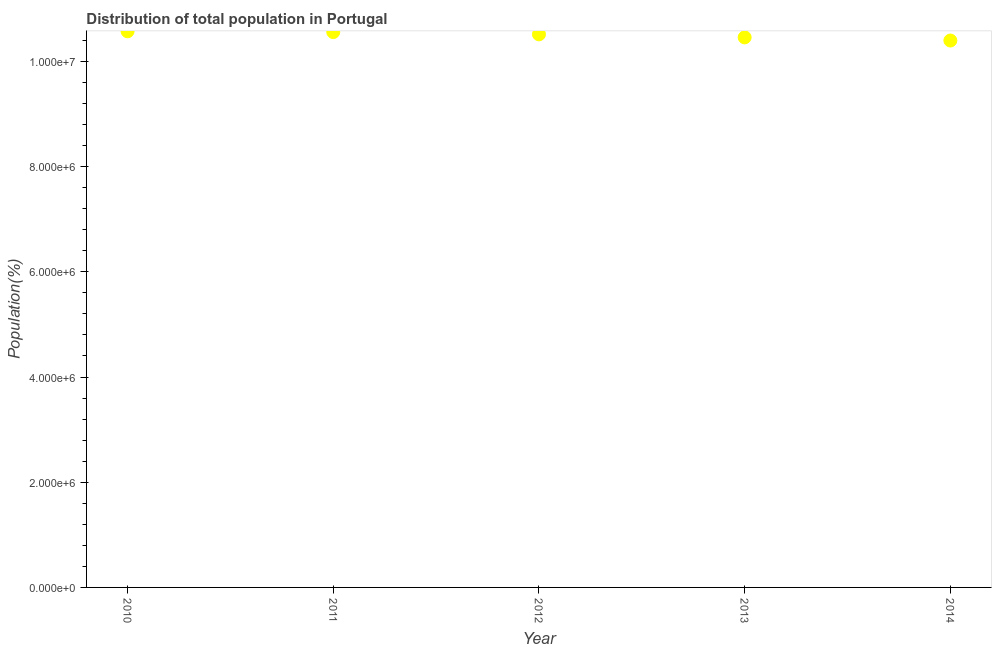What is the population in 2010?
Your answer should be compact. 1.06e+07. Across all years, what is the maximum population?
Provide a short and direct response. 1.06e+07. Across all years, what is the minimum population?
Keep it short and to the point. 1.04e+07. What is the sum of the population?
Your answer should be compact. 5.25e+07. What is the difference between the population in 2012 and 2014?
Keep it short and to the point. 1.17e+05. What is the average population per year?
Your answer should be compact. 1.05e+07. What is the median population?
Ensure brevity in your answer.  1.05e+07. Do a majority of the years between 2014 and 2010 (inclusive) have population greater than 7600000 %?
Ensure brevity in your answer.  Yes. What is the ratio of the population in 2011 to that in 2012?
Your answer should be compact. 1. Is the difference between the population in 2010 and 2012 greater than the difference between any two years?
Keep it short and to the point. No. What is the difference between the highest and the second highest population?
Provide a short and direct response. 1.55e+04. What is the difference between the highest and the lowest population?
Provide a succinct answer. 1.76e+05. Does the population monotonically increase over the years?
Provide a short and direct response. No. How many years are there in the graph?
Keep it short and to the point. 5. What is the difference between two consecutive major ticks on the Y-axis?
Provide a short and direct response. 2.00e+06. Are the values on the major ticks of Y-axis written in scientific E-notation?
Give a very brief answer. Yes. Does the graph contain grids?
Provide a short and direct response. No. What is the title of the graph?
Provide a succinct answer. Distribution of total population in Portugal . What is the label or title of the Y-axis?
Provide a succinct answer. Population(%). What is the Population(%) in 2010?
Your answer should be very brief. 1.06e+07. What is the Population(%) in 2011?
Keep it short and to the point. 1.06e+07. What is the Population(%) in 2012?
Give a very brief answer. 1.05e+07. What is the Population(%) in 2013?
Give a very brief answer. 1.05e+07. What is the Population(%) in 2014?
Your answer should be very brief. 1.04e+07. What is the difference between the Population(%) in 2010 and 2011?
Give a very brief answer. 1.55e+04. What is the difference between the Population(%) in 2010 and 2012?
Your answer should be compact. 5.83e+04. What is the difference between the Population(%) in 2010 and 2013?
Give a very brief answer. 1.16e+05. What is the difference between the Population(%) in 2010 and 2014?
Offer a very short reply. 1.76e+05. What is the difference between the Population(%) in 2011 and 2012?
Make the answer very short. 4.27e+04. What is the difference between the Population(%) in 2011 and 2013?
Offer a very short reply. 1.00e+05. What is the difference between the Population(%) in 2011 and 2014?
Your response must be concise. 1.60e+05. What is the difference between the Population(%) in 2012 and 2013?
Give a very brief answer. 5.75e+04. What is the difference between the Population(%) in 2012 and 2014?
Your answer should be very brief. 1.17e+05. What is the difference between the Population(%) in 2013 and 2014?
Your answer should be very brief. 5.99e+04. What is the ratio of the Population(%) in 2010 to that in 2011?
Provide a short and direct response. 1. What is the ratio of the Population(%) in 2010 to that in 2013?
Your response must be concise. 1.01. What is the ratio of the Population(%) in 2010 to that in 2014?
Provide a succinct answer. 1.02. What is the ratio of the Population(%) in 2011 to that in 2012?
Your answer should be very brief. 1. What is the ratio of the Population(%) in 2011 to that in 2013?
Make the answer very short. 1.01. What is the ratio of the Population(%) in 2012 to that in 2014?
Ensure brevity in your answer.  1.01. What is the ratio of the Population(%) in 2013 to that in 2014?
Make the answer very short. 1.01. 